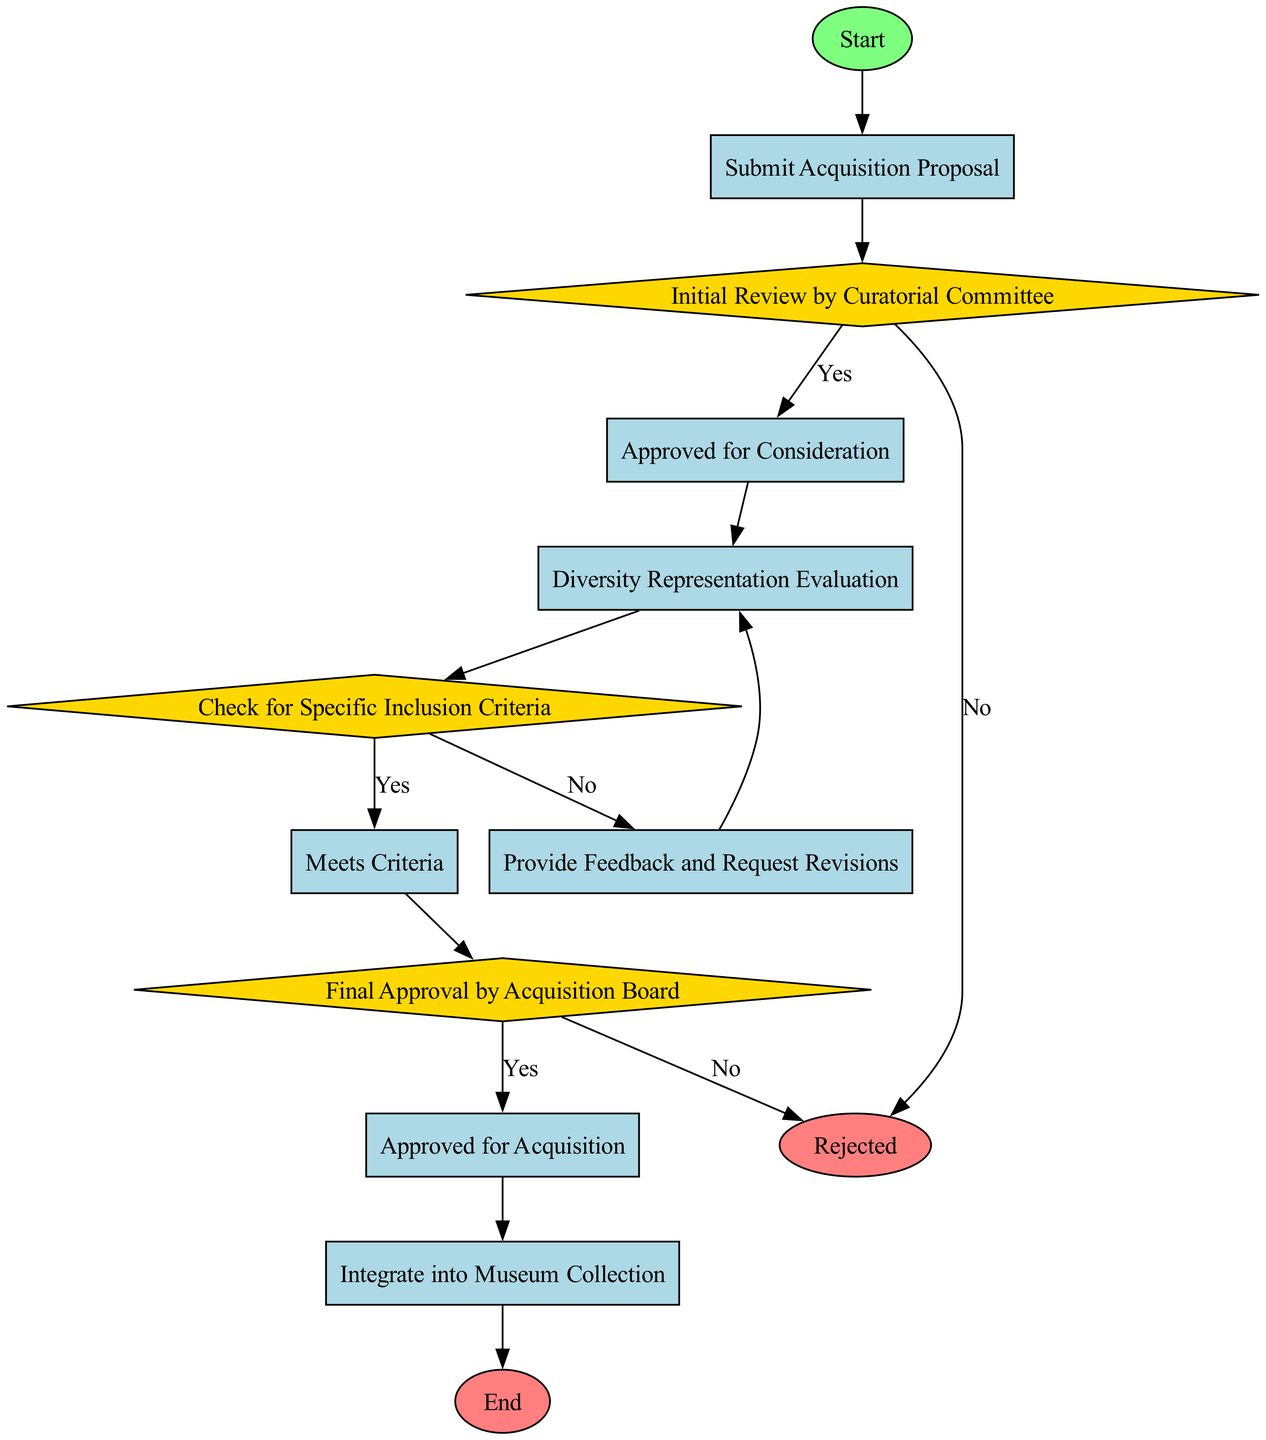What is the first step in the acquisition process? The first step is represented by the "Start" node, indicating the beginning of the process before any actions or decisions are made.
Answer: Start How many decision nodes are there in the flowchart? The flowchart contains three decision nodes: "Initial Review by Curatorial Committee," "Check for Specific Inclusion Criteria," and "Final Approval by Acquisition Board." Therefore, the total count of decision nodes is three.
Answer: 3 What happens if the proposal is rejected during the initial review? If the proposal is rejected during the "Initial Review by Curatorial Committee," it leads directly to the "Rejected" end node, indicating an end to the process without approval.
Answer: Rejected What step follows after the diversity representation evaluation? After the "Diversity Representation Evaluation" step, the next step is to "Check for Specific Inclusion Criteria," which is a decision-making process regarding the diversity aspects of the proposal.
Answer: Check for Specific Inclusion Criteria What is the outcome if the proposal does not meet the specific inclusion criteria? If the proposal does not meet the criteria during the "Check for Specific Inclusion Criteria" decision node, the process moves to the "Provide Feedback and Request Revisions" step, allowing for amendments to the proposal.
Answer: Provide Feedback and Request Revisions Explain the pathway if an acquisition proposal is approved for consideration. Once approved for consideration, the flow proceeds to the "Diversity Representation Evaluation." If approved in this evaluation, the process continues to "Check for Specific Inclusion Criteria" and further moves through the steps toward final approval. The entire path can be traced from "Approved for Consideration" to "Final Approval by Acquisition Board."
Answer: Approved for Consideration to Final Approval What is the last step before the acquisition is integrated into the museum collection? The penultimate step before integration into the museum collection is "Approved for Acquisition," which signifies that the proposal has successfully passed all evaluations and received final approval.
Answer: Approved for Acquisition What color represents the decision nodes in the diagram? Decision nodes in the flowchart are colored with a gold fill, as indicated by the style attributes defined for diamonds, which visually signify points of choice or evaluation within the process.
Answer: Gold 